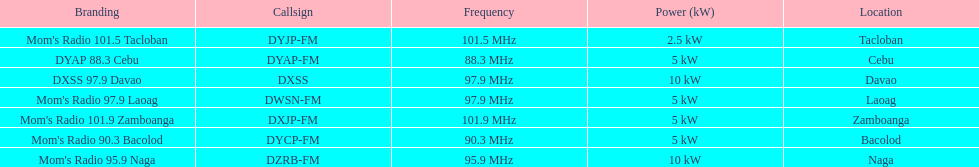What is the difference in kw between naga and bacolod radio? 5 kW. Could you parse the entire table as a dict? {'header': ['Branding', 'Callsign', 'Frequency', 'Power (kW)', 'Location'], 'rows': [["Mom's Radio 101.5 Tacloban", 'DYJP-FM', '101.5\xa0MHz', '2.5\xa0kW', 'Tacloban'], ['DYAP 88.3 Cebu', 'DYAP-FM', '88.3\xa0MHz', '5\xa0kW', 'Cebu'], ['DXSS 97.9 Davao', 'DXSS', '97.9\xa0MHz', '10\xa0kW', 'Davao'], ["Mom's Radio 97.9 Laoag", 'DWSN-FM', '97.9\xa0MHz', '5\xa0kW', 'Laoag'], ["Mom's Radio 101.9 Zamboanga", 'DXJP-FM', '101.9\xa0MHz', '5\xa0kW', 'Zamboanga'], ["Mom's Radio 90.3 Bacolod", 'DYCP-FM', '90.3\xa0MHz', '5\xa0kW', 'Bacolod'], ["Mom's Radio 95.9 Naga", 'DZRB-FM', '95.9\xa0MHz', '10\xa0kW', 'Naga']]} 